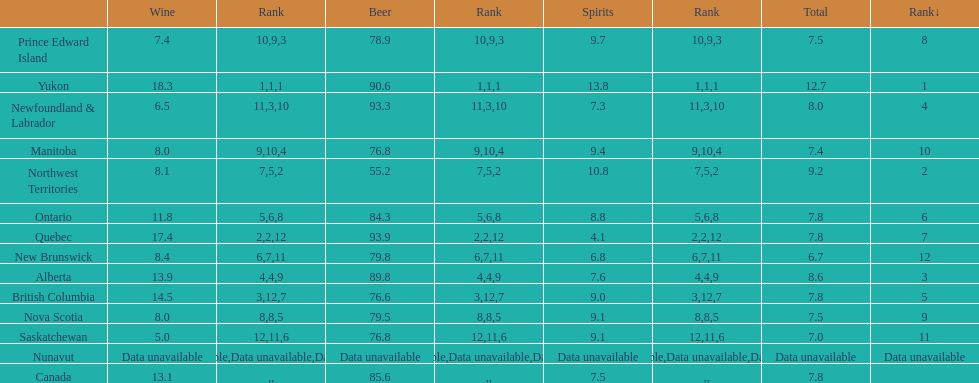What are the number of territories that have a wine consumption above 10.0? 5. 